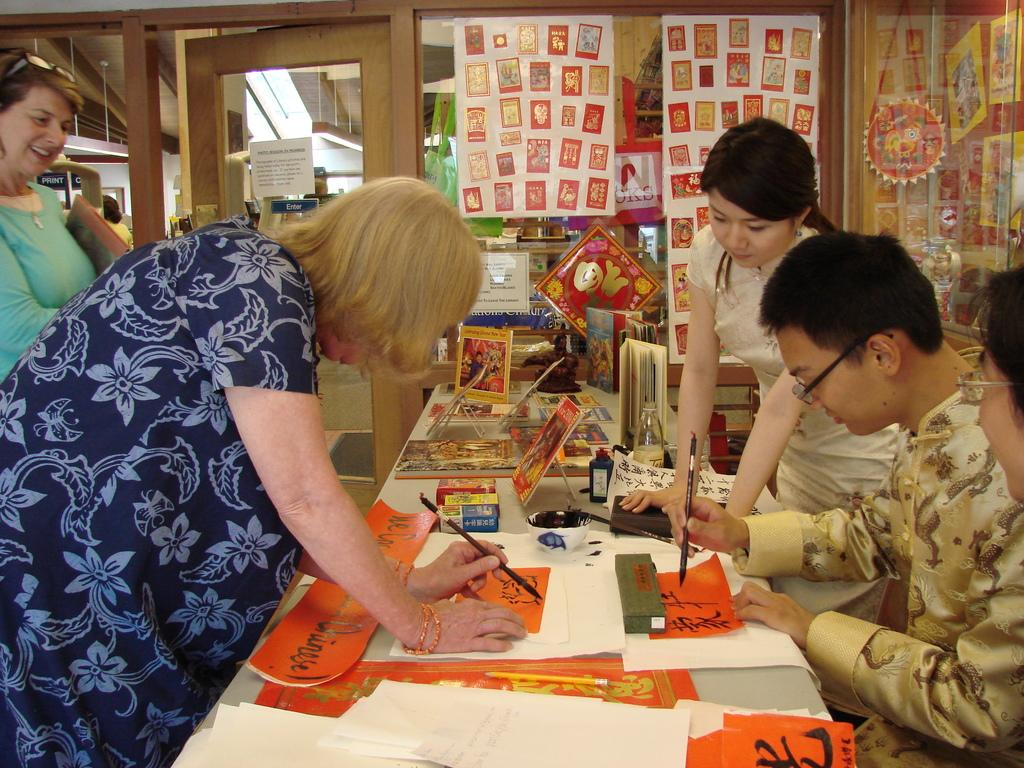What type of decorations are present in the image? There are posters in the image. Can you describe the people in the image? There are people in the image. What other items can be seen in the image besides posters and people? There are color papers in the image. What architectural feature is visible in the image? There is a door in the image. What piece of furniture is present in the image with objects placed on it? There is a wooden table with objects placed on it in the image. What type of boundary is visible in the image? There is no boundary present in the image. Can you describe the doll that is sitting on the wooden table in the image? There is no doll present in the image. What type of yak can be seen grazing near the wooden table in the image? There is no yak present in the image. 